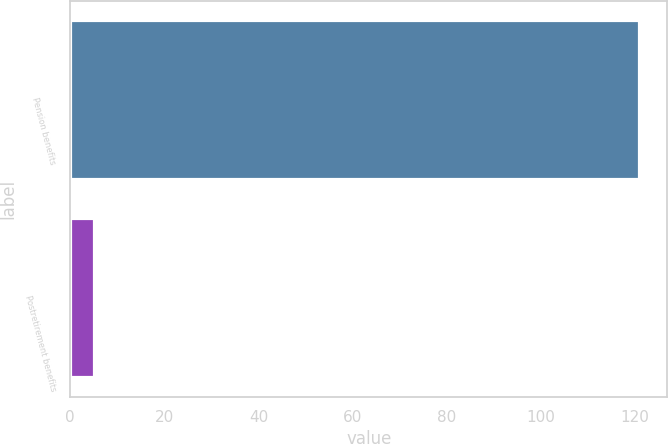Convert chart. <chart><loc_0><loc_0><loc_500><loc_500><bar_chart><fcel>Pension benefits<fcel>Postretirement benefits<nl><fcel>120.8<fcel>5.1<nl></chart> 